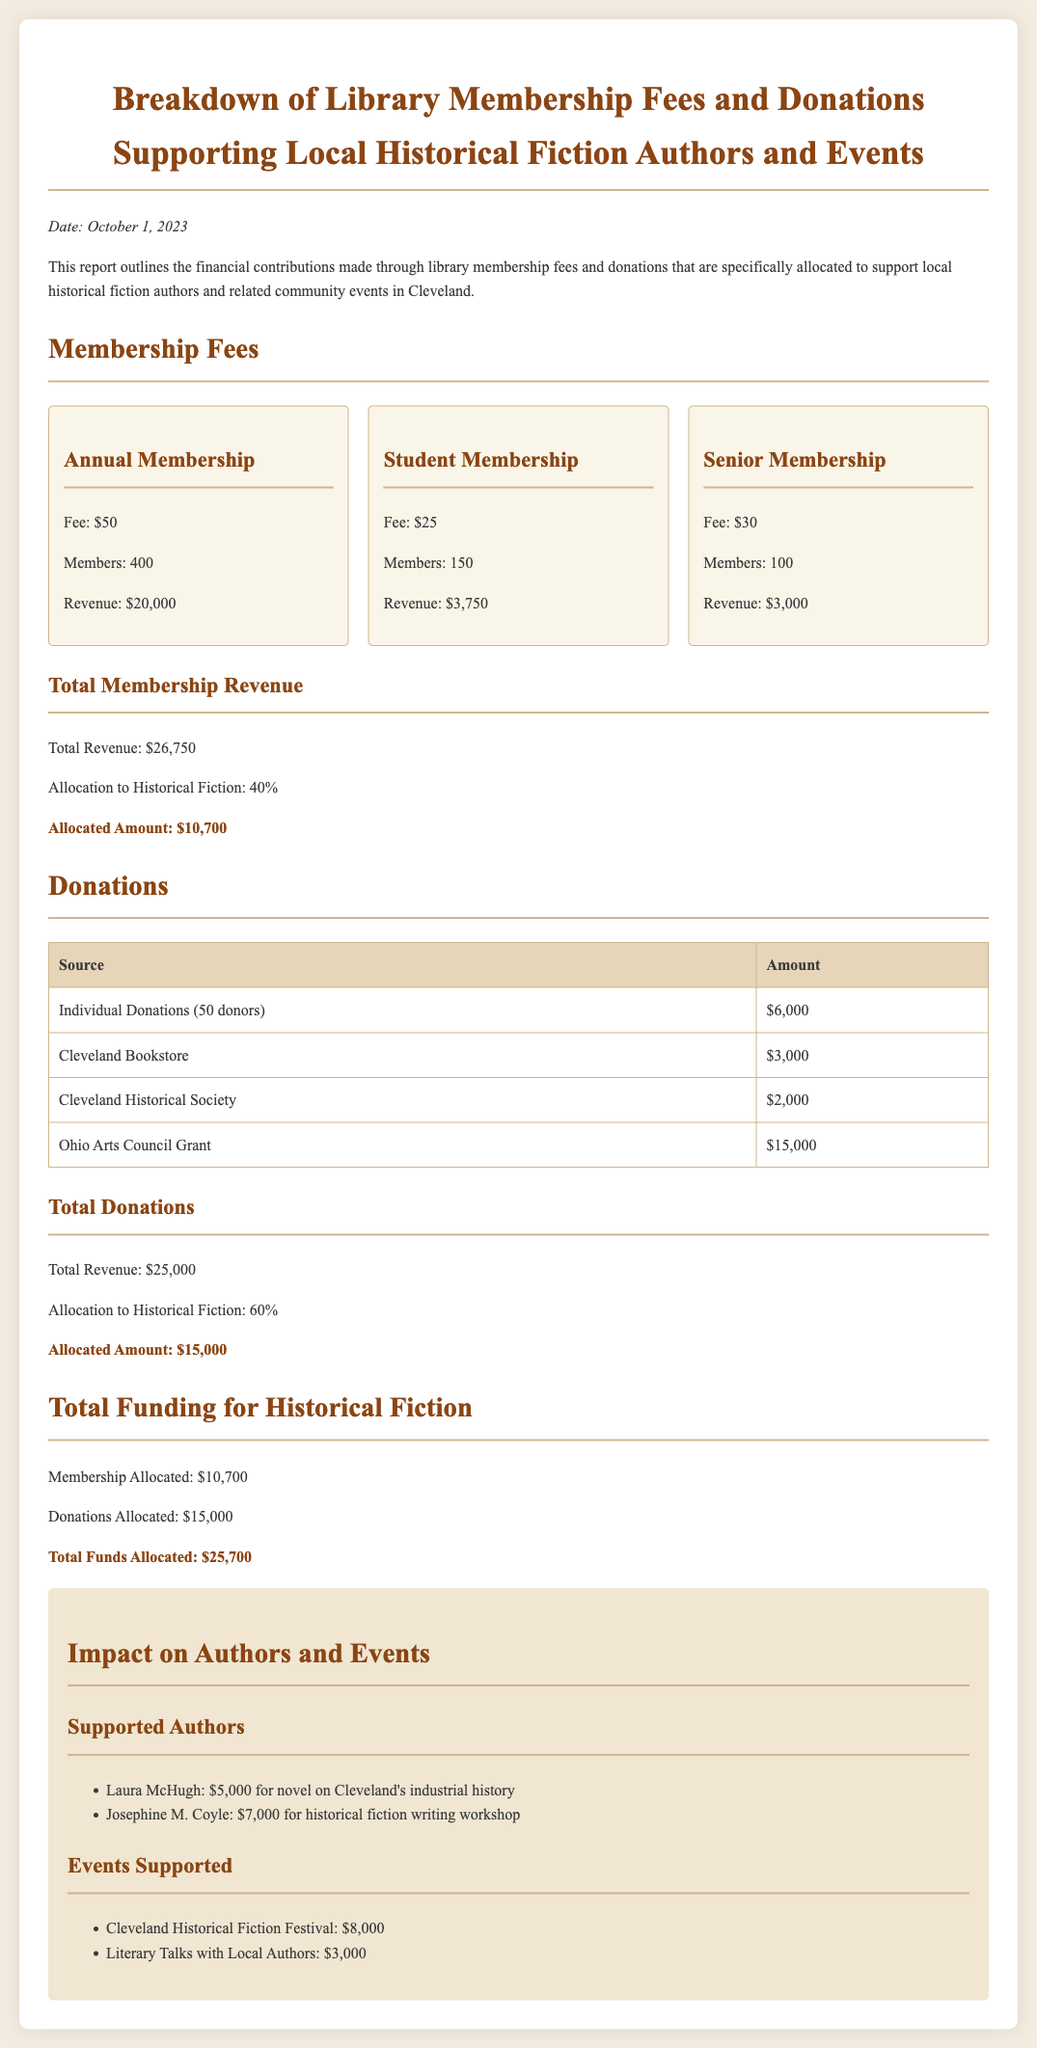What is the date of the report? The report is dated October 1, 2023, as mentioned in the introduction.
Answer: October 1, 2023 How many members are in the Annual Membership category? The document specifies that there are 400 members in the Annual Membership category.
Answer: 400 What is the allocated amount from membership fees to historical fiction? The allocated amount from membership fees to historical fiction is calculated as 40% of total membership revenue, which is $10,700.
Answer: $10,700 What percentage of total donations is allocated to historical fiction? The document states that 60% of total donations is allocated to historical fiction.
Answer: 60% Who received $7,000 for a historical fiction writing workshop? The report lists Josephine M. Coyle as the recipient of $7,000 for a historical fiction writing workshop.
Answer: Josephine M. Coyle What is the total funding allocated for historical fiction? The total funds allocated for historical fiction is the sum of the allocated amounts from both membership and donations, specifically $25,700.
Answer: $25,700 What is the revenue from Individual Donations? The revenue from Individual Donations is explicitly stated as $6,000 in the donations table.
Answer: $6,000 What kind of event is the Cleveland Historical Fiction Festival? The report describes it as an event that received funding of $8,000.
Answer: Festival Who is the Cleveland Historical Society? The document refers to it as a source of donations amounting to $2,000.
Answer: Cleveland Historical Society 